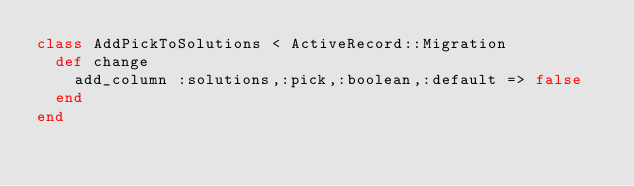<code> <loc_0><loc_0><loc_500><loc_500><_Ruby_>class AddPickToSolutions < ActiveRecord::Migration
  def change
    add_column :solutions,:pick,:boolean,:default => false
  end
end
</code> 